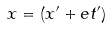<formula> <loc_0><loc_0><loc_500><loc_500>x = ( x ^ { \prime } + e t ^ { \prime } )</formula> 